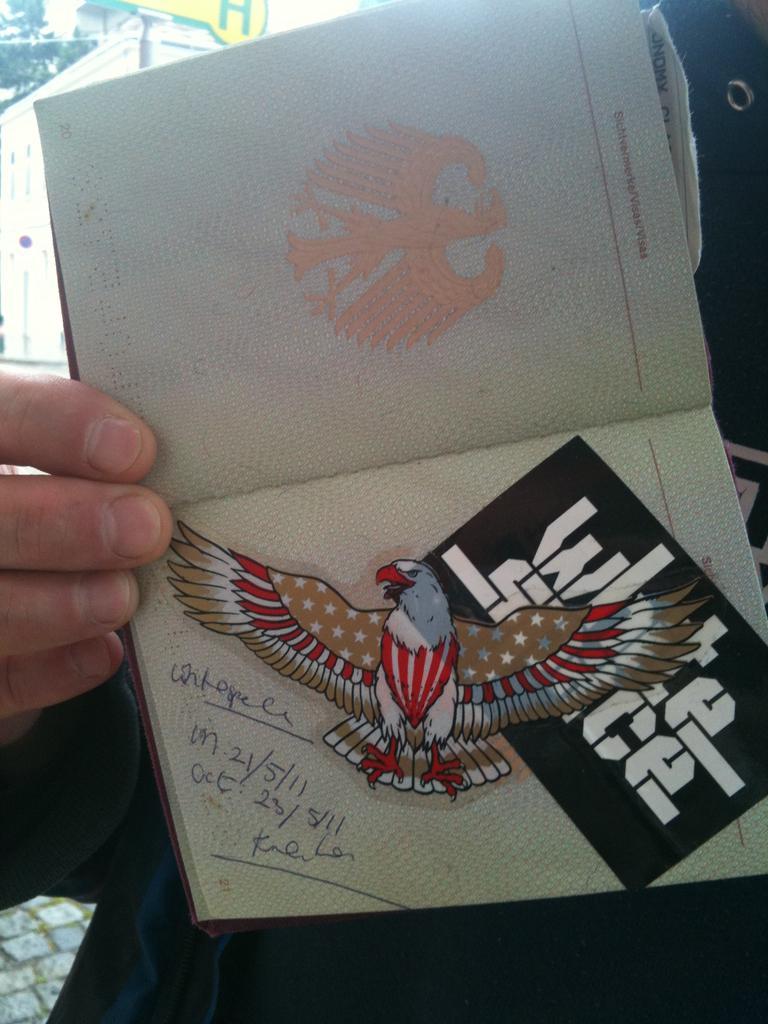Describe this image in one or two sentences. In this picture there is a person with black dress is standing and holding the book. There is a text and there is sticker of an eagle and card on the book. At the back there is a building and there is a tree. At the bottom there is a pavement. 